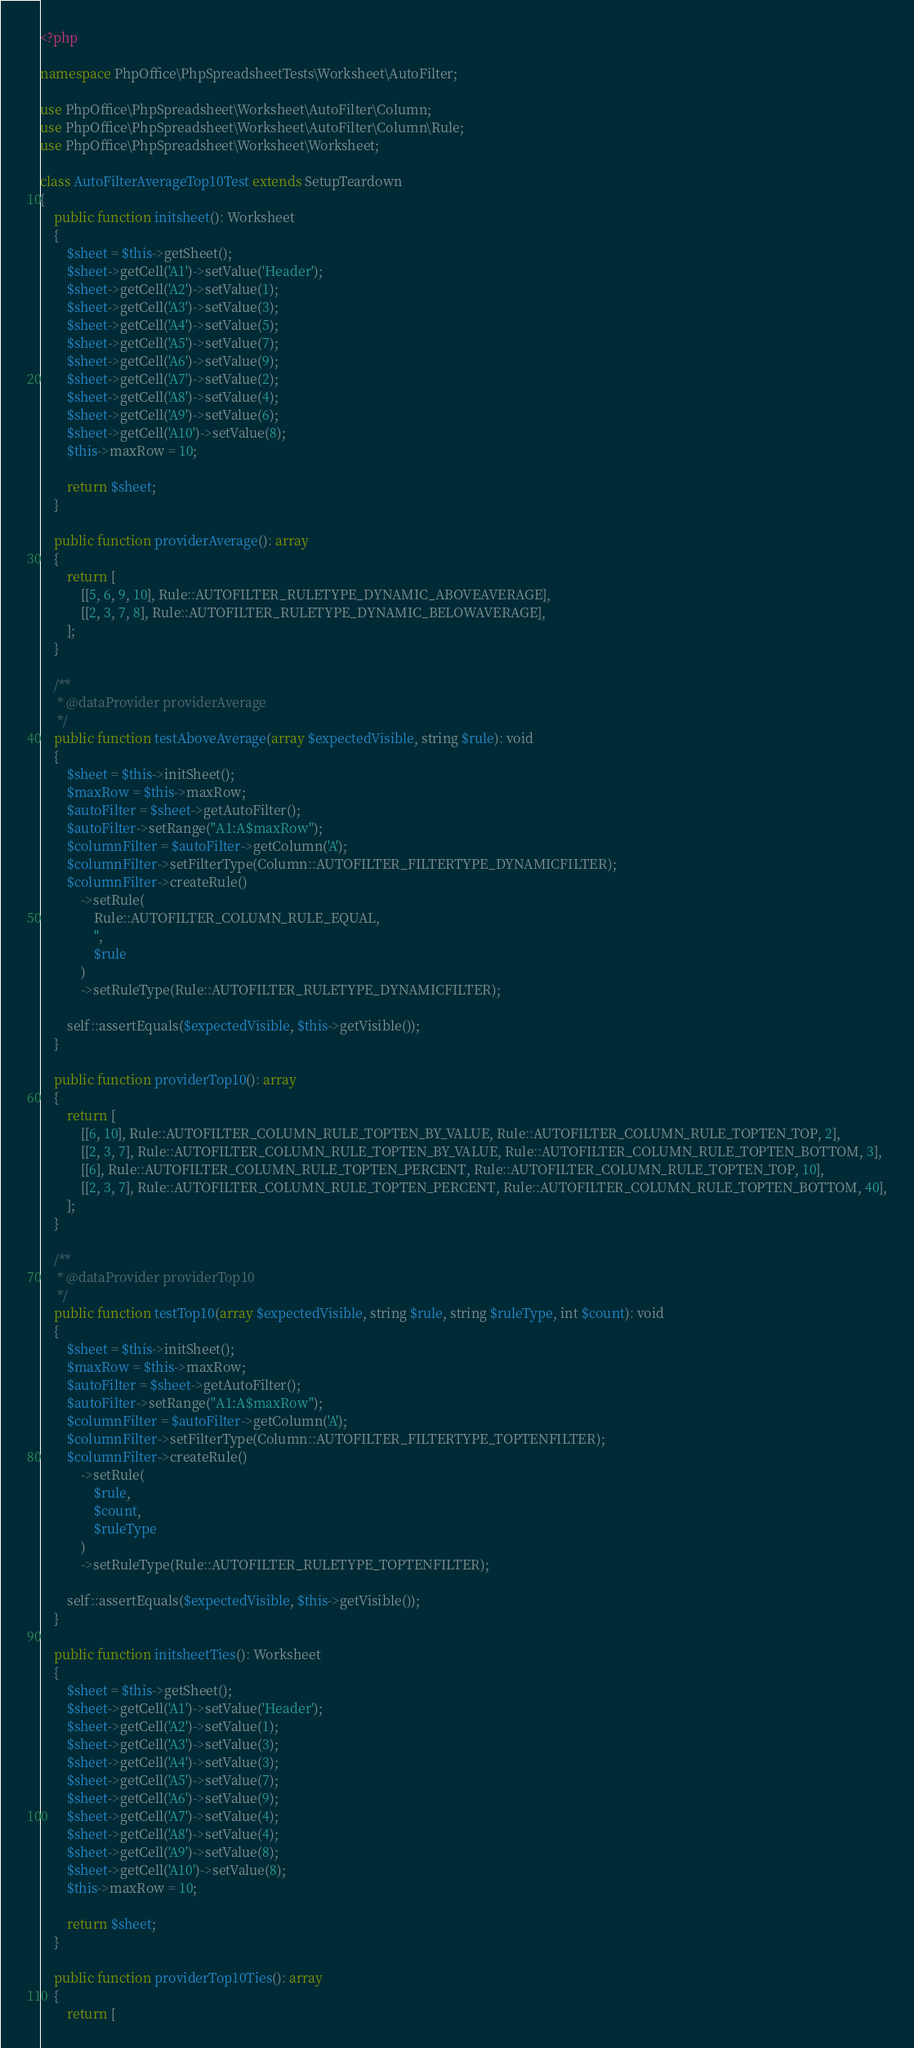<code> <loc_0><loc_0><loc_500><loc_500><_PHP_><?php

namespace PhpOffice\PhpSpreadsheetTests\Worksheet\AutoFilter;

use PhpOffice\PhpSpreadsheet\Worksheet\AutoFilter\Column;
use PhpOffice\PhpSpreadsheet\Worksheet\AutoFilter\Column\Rule;
use PhpOffice\PhpSpreadsheet\Worksheet\Worksheet;

class AutoFilterAverageTop10Test extends SetupTeardown
{
    public function initsheet(): Worksheet
    {
        $sheet = $this->getSheet();
        $sheet->getCell('A1')->setValue('Header');
        $sheet->getCell('A2')->setValue(1);
        $sheet->getCell('A3')->setValue(3);
        $sheet->getCell('A4')->setValue(5);
        $sheet->getCell('A5')->setValue(7);
        $sheet->getCell('A6')->setValue(9);
        $sheet->getCell('A7')->setValue(2);
        $sheet->getCell('A8')->setValue(4);
        $sheet->getCell('A9')->setValue(6);
        $sheet->getCell('A10')->setValue(8);
        $this->maxRow = 10;

        return $sheet;
    }

    public function providerAverage(): array
    {
        return [
            [[5, 6, 9, 10], Rule::AUTOFILTER_RULETYPE_DYNAMIC_ABOVEAVERAGE],
            [[2, 3, 7, 8], Rule::AUTOFILTER_RULETYPE_DYNAMIC_BELOWAVERAGE],
        ];
    }

    /**
     * @dataProvider providerAverage
     */
    public function testAboveAverage(array $expectedVisible, string $rule): void
    {
        $sheet = $this->initSheet();
        $maxRow = $this->maxRow;
        $autoFilter = $sheet->getAutoFilter();
        $autoFilter->setRange("A1:A$maxRow");
        $columnFilter = $autoFilter->getColumn('A');
        $columnFilter->setFilterType(Column::AUTOFILTER_FILTERTYPE_DYNAMICFILTER);
        $columnFilter->createRule()
            ->setRule(
                Rule::AUTOFILTER_COLUMN_RULE_EQUAL,
                '',
                $rule
            )
            ->setRuleType(Rule::AUTOFILTER_RULETYPE_DYNAMICFILTER);

        self::assertEquals($expectedVisible, $this->getVisible());
    }

    public function providerTop10(): array
    {
        return [
            [[6, 10], Rule::AUTOFILTER_COLUMN_RULE_TOPTEN_BY_VALUE, Rule::AUTOFILTER_COLUMN_RULE_TOPTEN_TOP, 2],
            [[2, 3, 7], Rule::AUTOFILTER_COLUMN_RULE_TOPTEN_BY_VALUE, Rule::AUTOFILTER_COLUMN_RULE_TOPTEN_BOTTOM, 3],
            [[6], Rule::AUTOFILTER_COLUMN_RULE_TOPTEN_PERCENT, Rule::AUTOFILTER_COLUMN_RULE_TOPTEN_TOP, 10],
            [[2, 3, 7], Rule::AUTOFILTER_COLUMN_RULE_TOPTEN_PERCENT, Rule::AUTOFILTER_COLUMN_RULE_TOPTEN_BOTTOM, 40],
        ];
    }

    /**
     * @dataProvider providerTop10
     */
    public function testTop10(array $expectedVisible, string $rule, string $ruleType, int $count): void
    {
        $sheet = $this->initSheet();
        $maxRow = $this->maxRow;
        $autoFilter = $sheet->getAutoFilter();
        $autoFilter->setRange("A1:A$maxRow");
        $columnFilter = $autoFilter->getColumn('A');
        $columnFilter->setFilterType(Column::AUTOFILTER_FILTERTYPE_TOPTENFILTER);
        $columnFilter->createRule()
            ->setRule(
                $rule,
                $count,
                $ruleType
            )
            ->setRuleType(Rule::AUTOFILTER_RULETYPE_TOPTENFILTER);

        self::assertEquals($expectedVisible, $this->getVisible());
    }

    public function initsheetTies(): Worksheet
    {
        $sheet = $this->getSheet();
        $sheet->getCell('A1')->setValue('Header');
        $sheet->getCell('A2')->setValue(1);
        $sheet->getCell('A3')->setValue(3);
        $sheet->getCell('A4')->setValue(3);
        $sheet->getCell('A5')->setValue(7);
        $sheet->getCell('A6')->setValue(9);
        $sheet->getCell('A7')->setValue(4);
        $sheet->getCell('A8')->setValue(4);
        $sheet->getCell('A9')->setValue(8);
        $sheet->getCell('A10')->setValue(8);
        $this->maxRow = 10;

        return $sheet;
    }

    public function providerTop10Ties(): array
    {
        return [</code> 